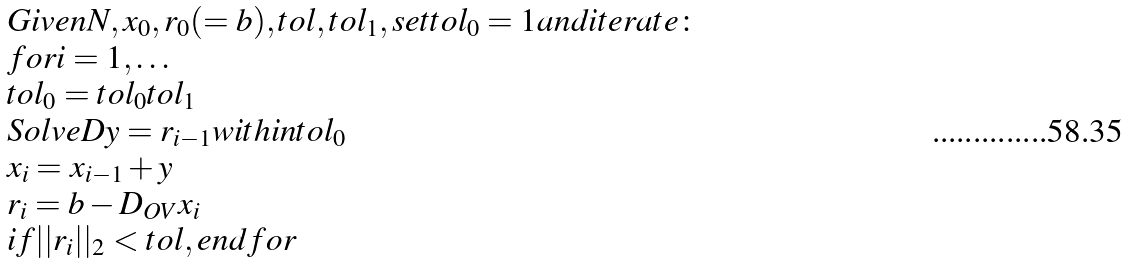Convert formula to latex. <formula><loc_0><loc_0><loc_500><loc_500>\begin{array} { l } G i v e n N , x _ { 0 } , r _ { 0 } ( = b ) , t o l , t o l _ { 1 } , s e t t o l _ { 0 } = 1 a n d i t e r a t e \colon \\ f o r i = 1 , \dots \\ t o l _ { 0 } = t o l _ { 0 } t o l _ { 1 } \\ S o l v e D y = r _ { i - 1 } w i t h i n t o l _ { 0 } \\ x _ { i } = x _ { i - 1 } + y \\ r _ { i } = b - D _ { O V } x _ { i } \\ i f | | r _ { i } | | _ { 2 } < t o l , e n d f o r \\ \end{array}</formula> 